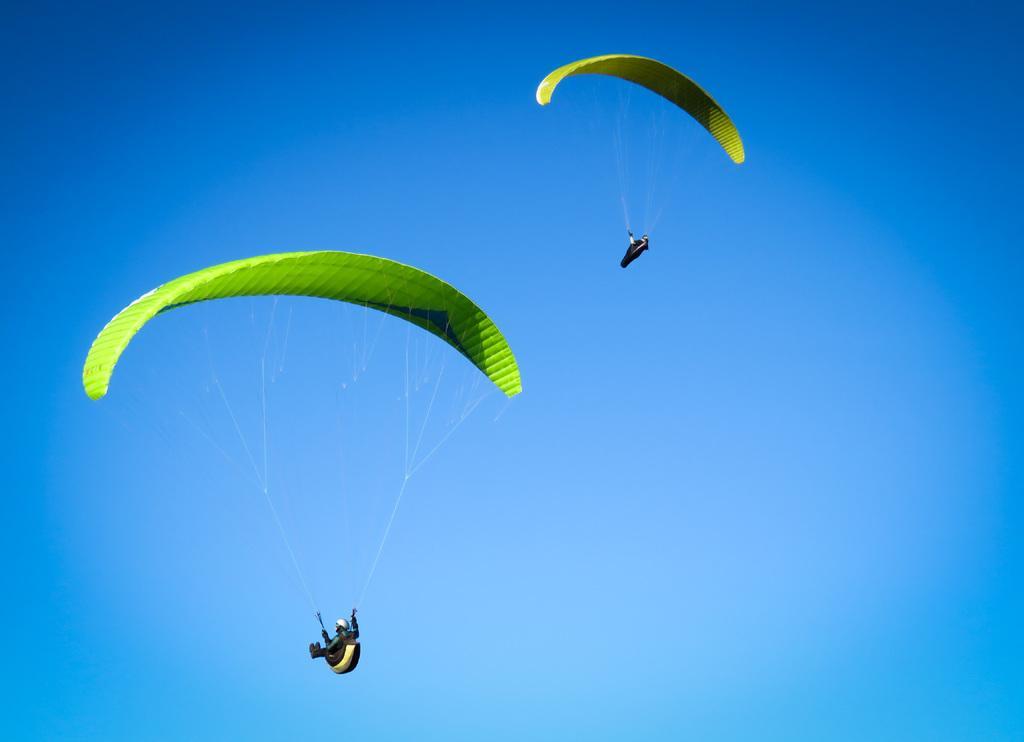How would you summarize this image in a sentence or two? This image consists of two parachutes in the air and the blue sky. 